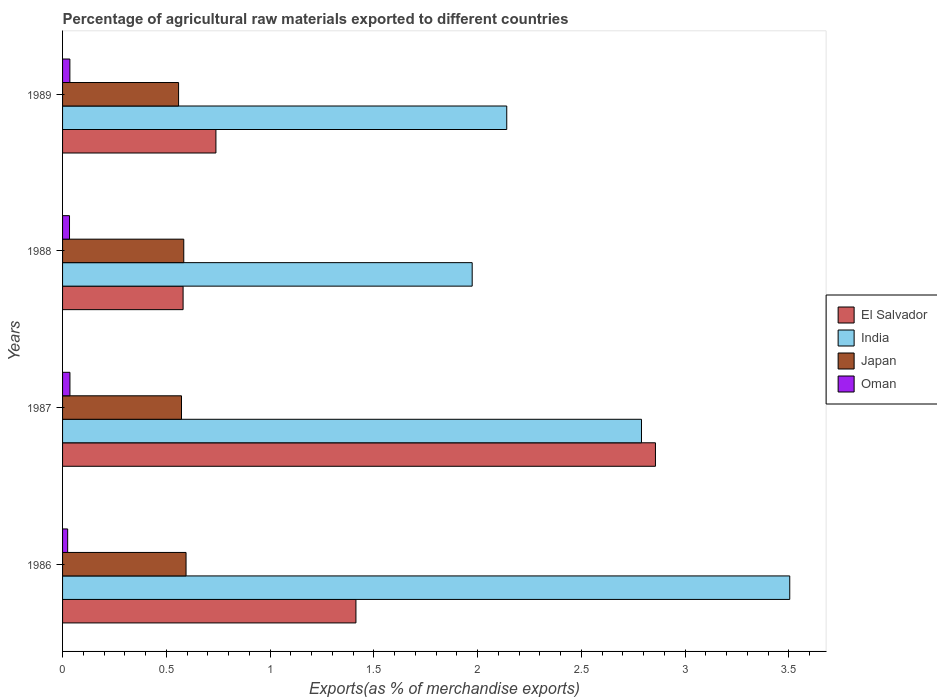How many different coloured bars are there?
Offer a terse response. 4. What is the label of the 3rd group of bars from the top?
Keep it short and to the point. 1987. What is the percentage of exports to different countries in Oman in 1989?
Make the answer very short. 0.04. Across all years, what is the maximum percentage of exports to different countries in Oman?
Give a very brief answer. 0.04. Across all years, what is the minimum percentage of exports to different countries in Oman?
Your response must be concise. 0.02. In which year was the percentage of exports to different countries in Oman maximum?
Give a very brief answer. 1987. What is the total percentage of exports to different countries in Oman in the graph?
Provide a succinct answer. 0.13. What is the difference between the percentage of exports to different countries in Japan in 1987 and that in 1989?
Make the answer very short. 0.01. What is the difference between the percentage of exports to different countries in Oman in 1987 and the percentage of exports to different countries in India in 1988?
Your answer should be compact. -1.94. What is the average percentage of exports to different countries in India per year?
Your response must be concise. 2.6. In the year 1987, what is the difference between the percentage of exports to different countries in El Salvador and percentage of exports to different countries in India?
Offer a terse response. 0.07. In how many years, is the percentage of exports to different countries in Japan greater than 3.5 %?
Make the answer very short. 0. What is the ratio of the percentage of exports to different countries in El Salvador in 1986 to that in 1989?
Your answer should be very brief. 1.91. Is the percentage of exports to different countries in India in 1987 less than that in 1988?
Ensure brevity in your answer.  No. Is the difference between the percentage of exports to different countries in El Salvador in 1986 and 1987 greater than the difference between the percentage of exports to different countries in India in 1986 and 1987?
Your response must be concise. No. What is the difference between the highest and the second highest percentage of exports to different countries in India?
Make the answer very short. 0.71. What is the difference between the highest and the lowest percentage of exports to different countries in El Salvador?
Give a very brief answer. 2.28. Is the sum of the percentage of exports to different countries in India in 1987 and 1988 greater than the maximum percentage of exports to different countries in Japan across all years?
Provide a short and direct response. Yes. What does the 3rd bar from the bottom in 1987 represents?
Provide a short and direct response. Japan. Is it the case that in every year, the sum of the percentage of exports to different countries in Japan and percentage of exports to different countries in El Salvador is greater than the percentage of exports to different countries in Oman?
Give a very brief answer. Yes. How many bars are there?
Make the answer very short. 16. Are all the bars in the graph horizontal?
Provide a short and direct response. Yes. Are the values on the major ticks of X-axis written in scientific E-notation?
Provide a short and direct response. No. Does the graph contain grids?
Make the answer very short. No. How many legend labels are there?
Make the answer very short. 4. How are the legend labels stacked?
Your answer should be compact. Vertical. What is the title of the graph?
Your answer should be very brief. Percentage of agricultural raw materials exported to different countries. Does "Comoros" appear as one of the legend labels in the graph?
Keep it short and to the point. No. What is the label or title of the X-axis?
Keep it short and to the point. Exports(as % of merchandise exports). What is the label or title of the Y-axis?
Offer a terse response. Years. What is the Exports(as % of merchandise exports) in El Salvador in 1986?
Give a very brief answer. 1.41. What is the Exports(as % of merchandise exports) of India in 1986?
Your response must be concise. 3.5. What is the Exports(as % of merchandise exports) in Japan in 1986?
Offer a terse response. 0.6. What is the Exports(as % of merchandise exports) in Oman in 1986?
Your answer should be very brief. 0.02. What is the Exports(as % of merchandise exports) in El Salvador in 1987?
Your answer should be compact. 2.86. What is the Exports(as % of merchandise exports) of India in 1987?
Your answer should be very brief. 2.79. What is the Exports(as % of merchandise exports) of Japan in 1987?
Provide a short and direct response. 0.57. What is the Exports(as % of merchandise exports) of Oman in 1987?
Make the answer very short. 0.04. What is the Exports(as % of merchandise exports) of El Salvador in 1988?
Your answer should be compact. 0.58. What is the Exports(as % of merchandise exports) of India in 1988?
Offer a terse response. 1.97. What is the Exports(as % of merchandise exports) of Japan in 1988?
Ensure brevity in your answer.  0.58. What is the Exports(as % of merchandise exports) in Oman in 1988?
Your answer should be very brief. 0.03. What is the Exports(as % of merchandise exports) in El Salvador in 1989?
Make the answer very short. 0.74. What is the Exports(as % of merchandise exports) of India in 1989?
Offer a very short reply. 2.14. What is the Exports(as % of merchandise exports) in Japan in 1989?
Your answer should be very brief. 0.56. What is the Exports(as % of merchandise exports) in Oman in 1989?
Your answer should be very brief. 0.04. Across all years, what is the maximum Exports(as % of merchandise exports) in El Salvador?
Your response must be concise. 2.86. Across all years, what is the maximum Exports(as % of merchandise exports) in India?
Your response must be concise. 3.5. Across all years, what is the maximum Exports(as % of merchandise exports) of Japan?
Keep it short and to the point. 0.6. Across all years, what is the maximum Exports(as % of merchandise exports) in Oman?
Offer a terse response. 0.04. Across all years, what is the minimum Exports(as % of merchandise exports) in El Salvador?
Keep it short and to the point. 0.58. Across all years, what is the minimum Exports(as % of merchandise exports) of India?
Ensure brevity in your answer.  1.97. Across all years, what is the minimum Exports(as % of merchandise exports) in Japan?
Your response must be concise. 0.56. Across all years, what is the minimum Exports(as % of merchandise exports) of Oman?
Make the answer very short. 0.02. What is the total Exports(as % of merchandise exports) in El Salvador in the graph?
Your response must be concise. 5.59. What is the total Exports(as % of merchandise exports) of India in the graph?
Your answer should be compact. 10.41. What is the total Exports(as % of merchandise exports) in Japan in the graph?
Provide a short and direct response. 2.31. What is the total Exports(as % of merchandise exports) of Oman in the graph?
Give a very brief answer. 0.13. What is the difference between the Exports(as % of merchandise exports) in El Salvador in 1986 and that in 1987?
Your response must be concise. -1.44. What is the difference between the Exports(as % of merchandise exports) of India in 1986 and that in 1987?
Your response must be concise. 0.71. What is the difference between the Exports(as % of merchandise exports) of Japan in 1986 and that in 1987?
Ensure brevity in your answer.  0.02. What is the difference between the Exports(as % of merchandise exports) of Oman in 1986 and that in 1987?
Your answer should be compact. -0.01. What is the difference between the Exports(as % of merchandise exports) of El Salvador in 1986 and that in 1988?
Your answer should be compact. 0.83. What is the difference between the Exports(as % of merchandise exports) of India in 1986 and that in 1988?
Provide a succinct answer. 1.53. What is the difference between the Exports(as % of merchandise exports) in Japan in 1986 and that in 1988?
Make the answer very short. 0.01. What is the difference between the Exports(as % of merchandise exports) of Oman in 1986 and that in 1988?
Offer a very short reply. -0.01. What is the difference between the Exports(as % of merchandise exports) in El Salvador in 1986 and that in 1989?
Your response must be concise. 0.67. What is the difference between the Exports(as % of merchandise exports) of India in 1986 and that in 1989?
Ensure brevity in your answer.  1.36. What is the difference between the Exports(as % of merchandise exports) in Japan in 1986 and that in 1989?
Your answer should be very brief. 0.04. What is the difference between the Exports(as % of merchandise exports) in Oman in 1986 and that in 1989?
Your answer should be very brief. -0.01. What is the difference between the Exports(as % of merchandise exports) of El Salvador in 1987 and that in 1988?
Give a very brief answer. 2.28. What is the difference between the Exports(as % of merchandise exports) in India in 1987 and that in 1988?
Offer a terse response. 0.82. What is the difference between the Exports(as % of merchandise exports) of Japan in 1987 and that in 1988?
Your answer should be very brief. -0.01. What is the difference between the Exports(as % of merchandise exports) of Oman in 1987 and that in 1988?
Make the answer very short. 0. What is the difference between the Exports(as % of merchandise exports) in El Salvador in 1987 and that in 1989?
Offer a terse response. 2.12. What is the difference between the Exports(as % of merchandise exports) in India in 1987 and that in 1989?
Your response must be concise. 0.65. What is the difference between the Exports(as % of merchandise exports) in Japan in 1987 and that in 1989?
Your answer should be compact. 0.01. What is the difference between the Exports(as % of merchandise exports) of Oman in 1987 and that in 1989?
Your response must be concise. 0. What is the difference between the Exports(as % of merchandise exports) of El Salvador in 1988 and that in 1989?
Offer a terse response. -0.16. What is the difference between the Exports(as % of merchandise exports) of India in 1988 and that in 1989?
Make the answer very short. -0.17. What is the difference between the Exports(as % of merchandise exports) in Japan in 1988 and that in 1989?
Your answer should be very brief. 0.03. What is the difference between the Exports(as % of merchandise exports) in Oman in 1988 and that in 1989?
Your answer should be very brief. -0. What is the difference between the Exports(as % of merchandise exports) of El Salvador in 1986 and the Exports(as % of merchandise exports) of India in 1987?
Provide a short and direct response. -1.38. What is the difference between the Exports(as % of merchandise exports) of El Salvador in 1986 and the Exports(as % of merchandise exports) of Japan in 1987?
Your answer should be very brief. 0.84. What is the difference between the Exports(as % of merchandise exports) in El Salvador in 1986 and the Exports(as % of merchandise exports) in Oman in 1987?
Offer a terse response. 1.38. What is the difference between the Exports(as % of merchandise exports) in India in 1986 and the Exports(as % of merchandise exports) in Japan in 1987?
Offer a very short reply. 2.93. What is the difference between the Exports(as % of merchandise exports) in India in 1986 and the Exports(as % of merchandise exports) in Oman in 1987?
Keep it short and to the point. 3.47. What is the difference between the Exports(as % of merchandise exports) of Japan in 1986 and the Exports(as % of merchandise exports) of Oman in 1987?
Offer a very short reply. 0.56. What is the difference between the Exports(as % of merchandise exports) in El Salvador in 1986 and the Exports(as % of merchandise exports) in India in 1988?
Give a very brief answer. -0.56. What is the difference between the Exports(as % of merchandise exports) in El Salvador in 1986 and the Exports(as % of merchandise exports) in Japan in 1988?
Offer a very short reply. 0.83. What is the difference between the Exports(as % of merchandise exports) of El Salvador in 1986 and the Exports(as % of merchandise exports) of Oman in 1988?
Your answer should be compact. 1.38. What is the difference between the Exports(as % of merchandise exports) in India in 1986 and the Exports(as % of merchandise exports) in Japan in 1988?
Your response must be concise. 2.92. What is the difference between the Exports(as % of merchandise exports) in India in 1986 and the Exports(as % of merchandise exports) in Oman in 1988?
Provide a succinct answer. 3.47. What is the difference between the Exports(as % of merchandise exports) in Japan in 1986 and the Exports(as % of merchandise exports) in Oman in 1988?
Provide a succinct answer. 0.56. What is the difference between the Exports(as % of merchandise exports) of El Salvador in 1986 and the Exports(as % of merchandise exports) of India in 1989?
Your response must be concise. -0.73. What is the difference between the Exports(as % of merchandise exports) in El Salvador in 1986 and the Exports(as % of merchandise exports) in Japan in 1989?
Ensure brevity in your answer.  0.85. What is the difference between the Exports(as % of merchandise exports) of El Salvador in 1986 and the Exports(as % of merchandise exports) of Oman in 1989?
Your answer should be very brief. 1.38. What is the difference between the Exports(as % of merchandise exports) in India in 1986 and the Exports(as % of merchandise exports) in Japan in 1989?
Keep it short and to the point. 2.95. What is the difference between the Exports(as % of merchandise exports) in India in 1986 and the Exports(as % of merchandise exports) in Oman in 1989?
Your response must be concise. 3.47. What is the difference between the Exports(as % of merchandise exports) of Japan in 1986 and the Exports(as % of merchandise exports) of Oman in 1989?
Offer a terse response. 0.56. What is the difference between the Exports(as % of merchandise exports) in El Salvador in 1987 and the Exports(as % of merchandise exports) in India in 1988?
Keep it short and to the point. 0.88. What is the difference between the Exports(as % of merchandise exports) in El Salvador in 1987 and the Exports(as % of merchandise exports) in Japan in 1988?
Provide a succinct answer. 2.27. What is the difference between the Exports(as % of merchandise exports) of El Salvador in 1987 and the Exports(as % of merchandise exports) of Oman in 1988?
Your response must be concise. 2.82. What is the difference between the Exports(as % of merchandise exports) in India in 1987 and the Exports(as % of merchandise exports) in Japan in 1988?
Your answer should be very brief. 2.21. What is the difference between the Exports(as % of merchandise exports) of India in 1987 and the Exports(as % of merchandise exports) of Oman in 1988?
Make the answer very short. 2.76. What is the difference between the Exports(as % of merchandise exports) of Japan in 1987 and the Exports(as % of merchandise exports) of Oman in 1988?
Keep it short and to the point. 0.54. What is the difference between the Exports(as % of merchandise exports) of El Salvador in 1987 and the Exports(as % of merchandise exports) of India in 1989?
Your answer should be compact. 0.72. What is the difference between the Exports(as % of merchandise exports) in El Salvador in 1987 and the Exports(as % of merchandise exports) in Japan in 1989?
Provide a succinct answer. 2.3. What is the difference between the Exports(as % of merchandise exports) in El Salvador in 1987 and the Exports(as % of merchandise exports) in Oman in 1989?
Offer a very short reply. 2.82. What is the difference between the Exports(as % of merchandise exports) of India in 1987 and the Exports(as % of merchandise exports) of Japan in 1989?
Offer a very short reply. 2.23. What is the difference between the Exports(as % of merchandise exports) of India in 1987 and the Exports(as % of merchandise exports) of Oman in 1989?
Offer a very short reply. 2.75. What is the difference between the Exports(as % of merchandise exports) of Japan in 1987 and the Exports(as % of merchandise exports) of Oman in 1989?
Keep it short and to the point. 0.54. What is the difference between the Exports(as % of merchandise exports) of El Salvador in 1988 and the Exports(as % of merchandise exports) of India in 1989?
Offer a very short reply. -1.56. What is the difference between the Exports(as % of merchandise exports) in El Salvador in 1988 and the Exports(as % of merchandise exports) in Japan in 1989?
Keep it short and to the point. 0.02. What is the difference between the Exports(as % of merchandise exports) in El Salvador in 1988 and the Exports(as % of merchandise exports) in Oman in 1989?
Your response must be concise. 0.55. What is the difference between the Exports(as % of merchandise exports) of India in 1988 and the Exports(as % of merchandise exports) of Japan in 1989?
Keep it short and to the point. 1.41. What is the difference between the Exports(as % of merchandise exports) in India in 1988 and the Exports(as % of merchandise exports) in Oman in 1989?
Offer a terse response. 1.94. What is the difference between the Exports(as % of merchandise exports) of Japan in 1988 and the Exports(as % of merchandise exports) of Oman in 1989?
Make the answer very short. 0.55. What is the average Exports(as % of merchandise exports) in El Salvador per year?
Your answer should be compact. 1.4. What is the average Exports(as % of merchandise exports) in India per year?
Provide a short and direct response. 2.6. What is the average Exports(as % of merchandise exports) in Japan per year?
Provide a succinct answer. 0.58. What is the average Exports(as % of merchandise exports) of Oman per year?
Provide a short and direct response. 0.03. In the year 1986, what is the difference between the Exports(as % of merchandise exports) of El Salvador and Exports(as % of merchandise exports) of India?
Your answer should be very brief. -2.09. In the year 1986, what is the difference between the Exports(as % of merchandise exports) in El Salvador and Exports(as % of merchandise exports) in Japan?
Make the answer very short. 0.82. In the year 1986, what is the difference between the Exports(as % of merchandise exports) of El Salvador and Exports(as % of merchandise exports) of Oman?
Give a very brief answer. 1.39. In the year 1986, what is the difference between the Exports(as % of merchandise exports) in India and Exports(as % of merchandise exports) in Japan?
Your answer should be very brief. 2.91. In the year 1986, what is the difference between the Exports(as % of merchandise exports) of India and Exports(as % of merchandise exports) of Oman?
Offer a terse response. 3.48. In the year 1986, what is the difference between the Exports(as % of merchandise exports) in Japan and Exports(as % of merchandise exports) in Oman?
Provide a succinct answer. 0.57. In the year 1987, what is the difference between the Exports(as % of merchandise exports) of El Salvador and Exports(as % of merchandise exports) of India?
Offer a terse response. 0.07. In the year 1987, what is the difference between the Exports(as % of merchandise exports) in El Salvador and Exports(as % of merchandise exports) in Japan?
Offer a very short reply. 2.28. In the year 1987, what is the difference between the Exports(as % of merchandise exports) of El Salvador and Exports(as % of merchandise exports) of Oman?
Offer a terse response. 2.82. In the year 1987, what is the difference between the Exports(as % of merchandise exports) of India and Exports(as % of merchandise exports) of Japan?
Your answer should be very brief. 2.22. In the year 1987, what is the difference between the Exports(as % of merchandise exports) in India and Exports(as % of merchandise exports) in Oman?
Give a very brief answer. 2.75. In the year 1987, what is the difference between the Exports(as % of merchandise exports) in Japan and Exports(as % of merchandise exports) in Oman?
Offer a very short reply. 0.54. In the year 1988, what is the difference between the Exports(as % of merchandise exports) in El Salvador and Exports(as % of merchandise exports) in India?
Make the answer very short. -1.39. In the year 1988, what is the difference between the Exports(as % of merchandise exports) in El Salvador and Exports(as % of merchandise exports) in Japan?
Offer a very short reply. -0. In the year 1988, what is the difference between the Exports(as % of merchandise exports) of El Salvador and Exports(as % of merchandise exports) of Oman?
Keep it short and to the point. 0.55. In the year 1988, what is the difference between the Exports(as % of merchandise exports) of India and Exports(as % of merchandise exports) of Japan?
Your response must be concise. 1.39. In the year 1988, what is the difference between the Exports(as % of merchandise exports) of India and Exports(as % of merchandise exports) of Oman?
Offer a very short reply. 1.94. In the year 1988, what is the difference between the Exports(as % of merchandise exports) of Japan and Exports(as % of merchandise exports) of Oman?
Offer a very short reply. 0.55. In the year 1989, what is the difference between the Exports(as % of merchandise exports) of El Salvador and Exports(as % of merchandise exports) of India?
Your response must be concise. -1.4. In the year 1989, what is the difference between the Exports(as % of merchandise exports) of El Salvador and Exports(as % of merchandise exports) of Japan?
Your response must be concise. 0.18. In the year 1989, what is the difference between the Exports(as % of merchandise exports) in El Salvador and Exports(as % of merchandise exports) in Oman?
Make the answer very short. 0.7. In the year 1989, what is the difference between the Exports(as % of merchandise exports) of India and Exports(as % of merchandise exports) of Japan?
Offer a terse response. 1.58. In the year 1989, what is the difference between the Exports(as % of merchandise exports) in India and Exports(as % of merchandise exports) in Oman?
Keep it short and to the point. 2.11. In the year 1989, what is the difference between the Exports(as % of merchandise exports) in Japan and Exports(as % of merchandise exports) in Oman?
Your answer should be very brief. 0.52. What is the ratio of the Exports(as % of merchandise exports) of El Salvador in 1986 to that in 1987?
Give a very brief answer. 0.49. What is the ratio of the Exports(as % of merchandise exports) of India in 1986 to that in 1987?
Offer a very short reply. 1.26. What is the ratio of the Exports(as % of merchandise exports) in Japan in 1986 to that in 1987?
Provide a succinct answer. 1.04. What is the ratio of the Exports(as % of merchandise exports) of Oman in 1986 to that in 1987?
Provide a short and direct response. 0.69. What is the ratio of the Exports(as % of merchandise exports) of El Salvador in 1986 to that in 1988?
Offer a terse response. 2.43. What is the ratio of the Exports(as % of merchandise exports) in India in 1986 to that in 1988?
Provide a short and direct response. 1.78. What is the ratio of the Exports(as % of merchandise exports) of Japan in 1986 to that in 1988?
Ensure brevity in your answer.  1.02. What is the ratio of the Exports(as % of merchandise exports) in Oman in 1986 to that in 1988?
Make the answer very short. 0.73. What is the ratio of the Exports(as % of merchandise exports) in El Salvador in 1986 to that in 1989?
Your answer should be compact. 1.91. What is the ratio of the Exports(as % of merchandise exports) of India in 1986 to that in 1989?
Your answer should be compact. 1.64. What is the ratio of the Exports(as % of merchandise exports) of Japan in 1986 to that in 1989?
Make the answer very short. 1.06. What is the ratio of the Exports(as % of merchandise exports) in Oman in 1986 to that in 1989?
Give a very brief answer. 0.7. What is the ratio of the Exports(as % of merchandise exports) of El Salvador in 1987 to that in 1988?
Your answer should be very brief. 4.92. What is the ratio of the Exports(as % of merchandise exports) of India in 1987 to that in 1988?
Offer a very short reply. 1.41. What is the ratio of the Exports(as % of merchandise exports) of Japan in 1987 to that in 1988?
Offer a terse response. 0.98. What is the ratio of the Exports(as % of merchandise exports) of Oman in 1987 to that in 1988?
Make the answer very short. 1.06. What is the ratio of the Exports(as % of merchandise exports) in El Salvador in 1987 to that in 1989?
Give a very brief answer. 3.87. What is the ratio of the Exports(as % of merchandise exports) in India in 1987 to that in 1989?
Provide a succinct answer. 1.3. What is the ratio of the Exports(as % of merchandise exports) in Japan in 1987 to that in 1989?
Make the answer very short. 1.03. What is the ratio of the Exports(as % of merchandise exports) in Oman in 1987 to that in 1989?
Your answer should be compact. 1.01. What is the ratio of the Exports(as % of merchandise exports) in El Salvador in 1988 to that in 1989?
Offer a very short reply. 0.79. What is the ratio of the Exports(as % of merchandise exports) in India in 1988 to that in 1989?
Offer a very short reply. 0.92. What is the ratio of the Exports(as % of merchandise exports) in Japan in 1988 to that in 1989?
Give a very brief answer. 1.04. What is the ratio of the Exports(as % of merchandise exports) of Oman in 1988 to that in 1989?
Make the answer very short. 0.95. What is the difference between the highest and the second highest Exports(as % of merchandise exports) of El Salvador?
Your answer should be very brief. 1.44. What is the difference between the highest and the second highest Exports(as % of merchandise exports) of India?
Provide a short and direct response. 0.71. What is the difference between the highest and the second highest Exports(as % of merchandise exports) in Japan?
Offer a very short reply. 0.01. What is the difference between the highest and the lowest Exports(as % of merchandise exports) in El Salvador?
Provide a succinct answer. 2.28. What is the difference between the highest and the lowest Exports(as % of merchandise exports) in India?
Provide a short and direct response. 1.53. What is the difference between the highest and the lowest Exports(as % of merchandise exports) of Japan?
Make the answer very short. 0.04. What is the difference between the highest and the lowest Exports(as % of merchandise exports) of Oman?
Your answer should be very brief. 0.01. 